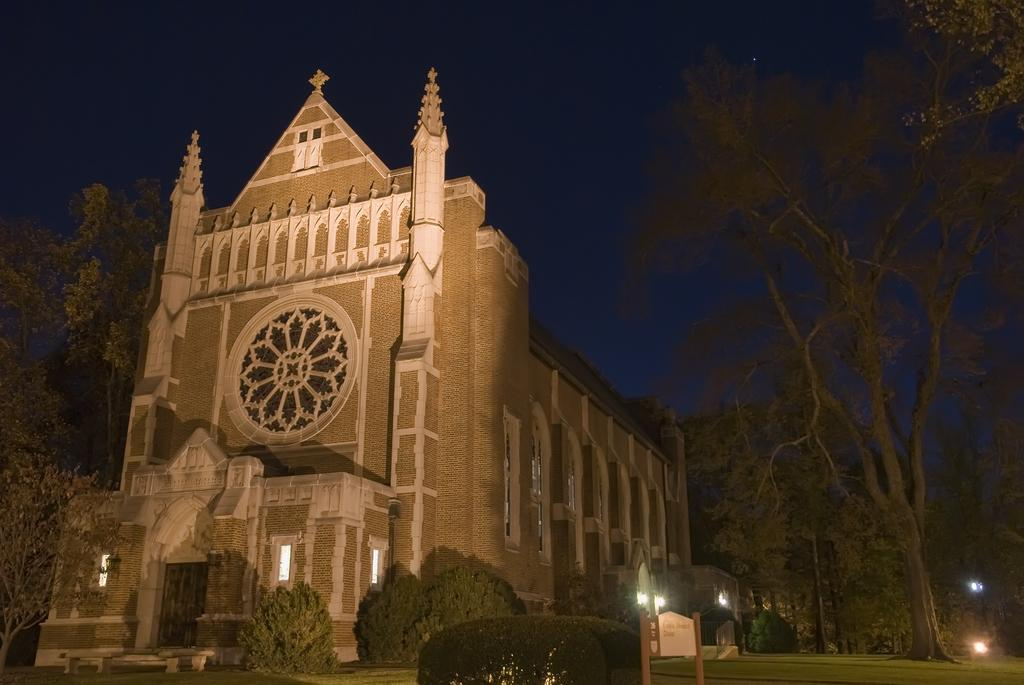What type of structure is visible in the image? There is a building in the image. What natural elements can be seen in the image? There are trees in the image. What man-made objects are present in the image? There are street light poles in the image. Can you see a robin using a quill to light a match in the image? No, there is no robin, quill, or match present in the image. 